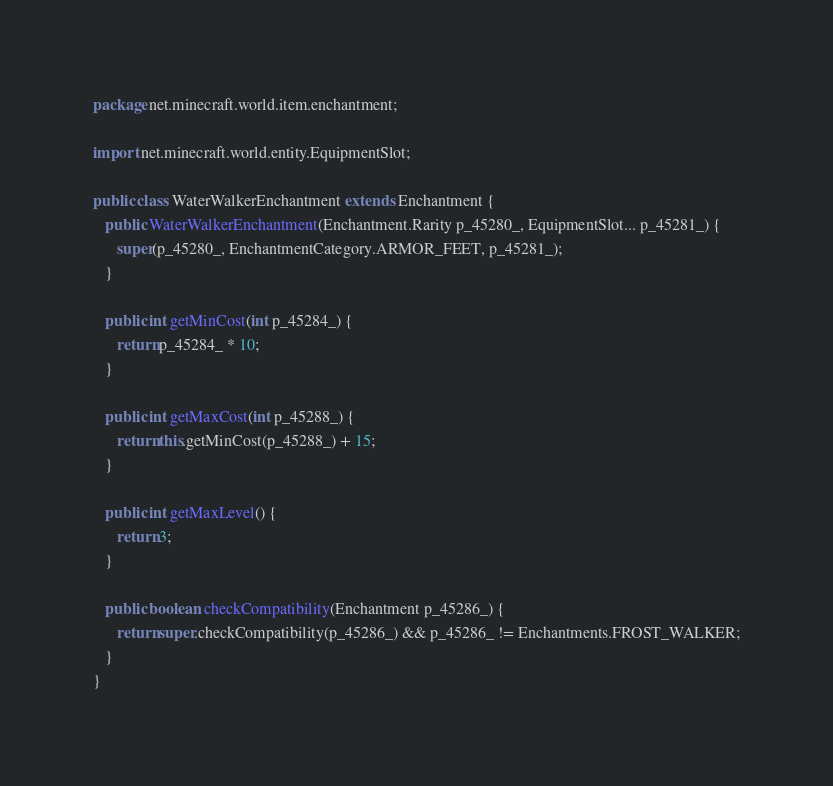Convert code to text. <code><loc_0><loc_0><loc_500><loc_500><_Java_>package net.minecraft.world.item.enchantment;

import net.minecraft.world.entity.EquipmentSlot;

public class WaterWalkerEnchantment extends Enchantment {
   public WaterWalkerEnchantment(Enchantment.Rarity p_45280_, EquipmentSlot... p_45281_) {
      super(p_45280_, EnchantmentCategory.ARMOR_FEET, p_45281_);
   }

   public int getMinCost(int p_45284_) {
      return p_45284_ * 10;
   }

   public int getMaxCost(int p_45288_) {
      return this.getMinCost(p_45288_) + 15;
   }

   public int getMaxLevel() {
      return 3;
   }

   public boolean checkCompatibility(Enchantment p_45286_) {
      return super.checkCompatibility(p_45286_) && p_45286_ != Enchantments.FROST_WALKER;
   }
}</code> 